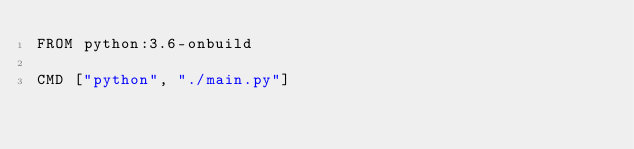<code> <loc_0><loc_0><loc_500><loc_500><_Dockerfile_>FROM python:3.6-onbuild

CMD ["python", "./main.py"]
</code> 